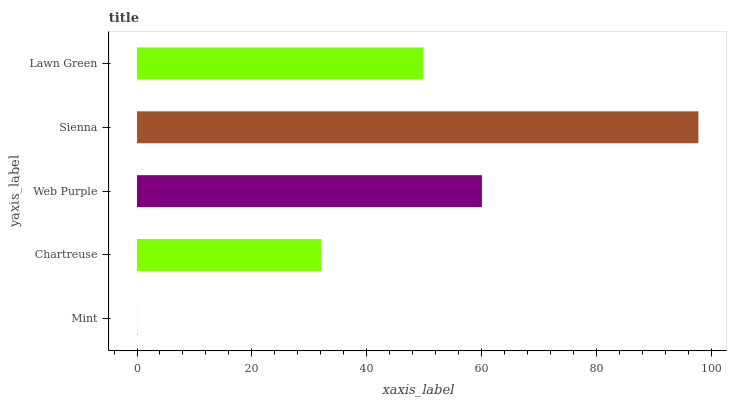Is Mint the minimum?
Answer yes or no. Yes. Is Sienna the maximum?
Answer yes or no. Yes. Is Chartreuse the minimum?
Answer yes or no. No. Is Chartreuse the maximum?
Answer yes or no. No. Is Chartreuse greater than Mint?
Answer yes or no. Yes. Is Mint less than Chartreuse?
Answer yes or no. Yes. Is Mint greater than Chartreuse?
Answer yes or no. No. Is Chartreuse less than Mint?
Answer yes or no. No. Is Lawn Green the high median?
Answer yes or no. Yes. Is Lawn Green the low median?
Answer yes or no. Yes. Is Chartreuse the high median?
Answer yes or no. No. Is Web Purple the low median?
Answer yes or no. No. 